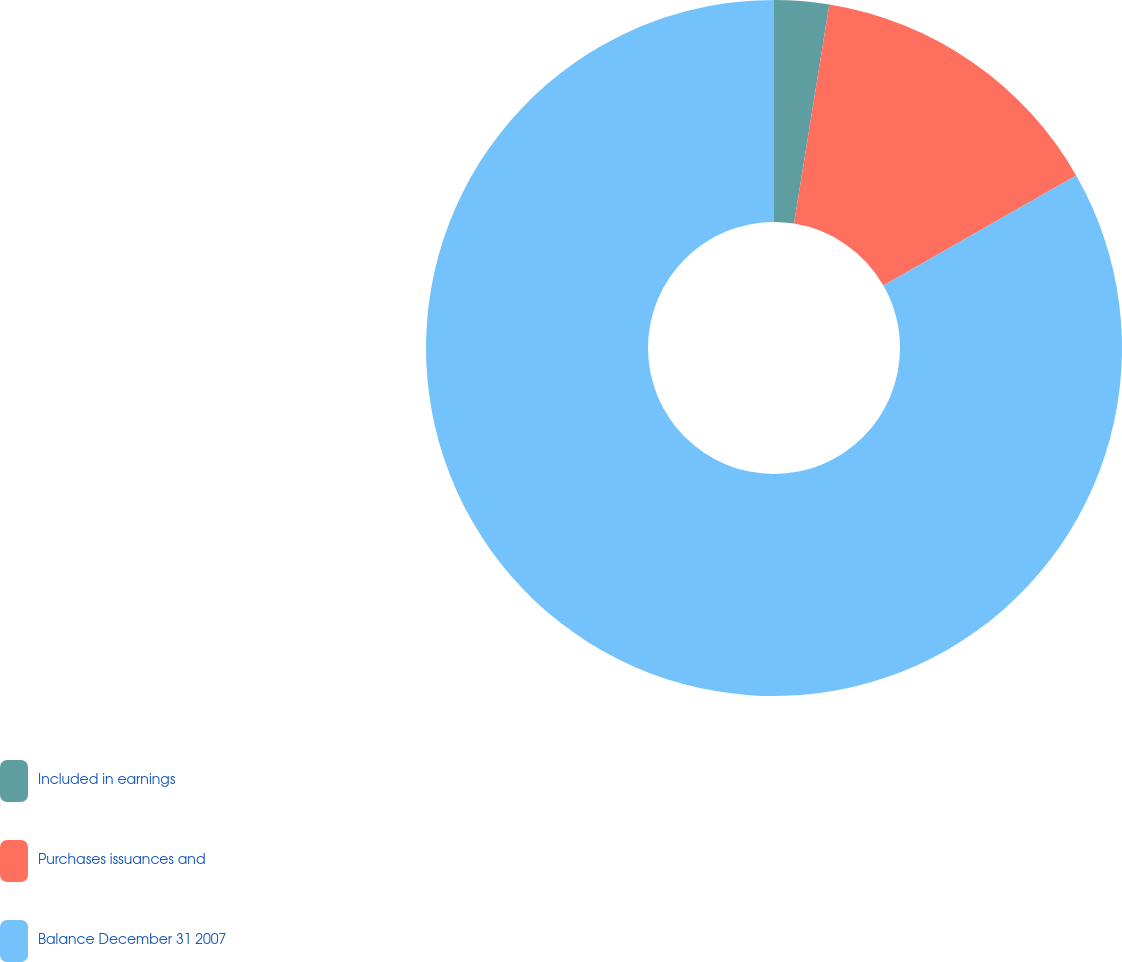Convert chart. <chart><loc_0><loc_0><loc_500><loc_500><pie_chart><fcel>Included in earnings<fcel>Purchases issuances and<fcel>Balance December 31 2007<nl><fcel>2.54%<fcel>14.2%<fcel>83.26%<nl></chart> 